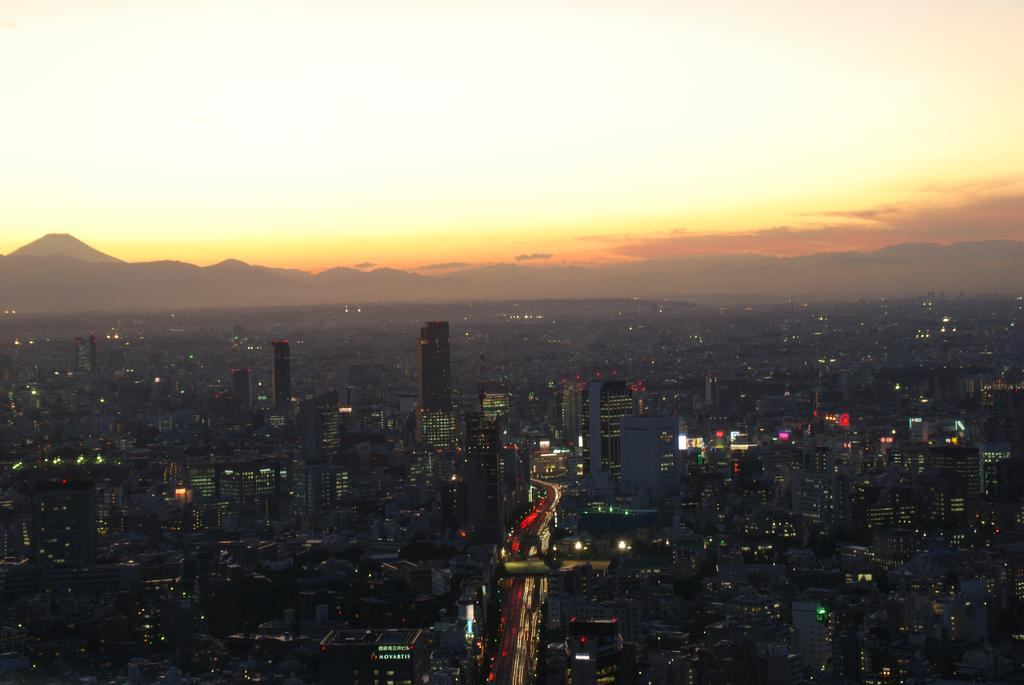What type of structures can be seen in the image? There are buildings in the image. What else is visible in the image besides the buildings? There are lights and hills visible in the image. What direction is the father walking in the image? There is no father present in the image, so it is not possible to answer that question. 